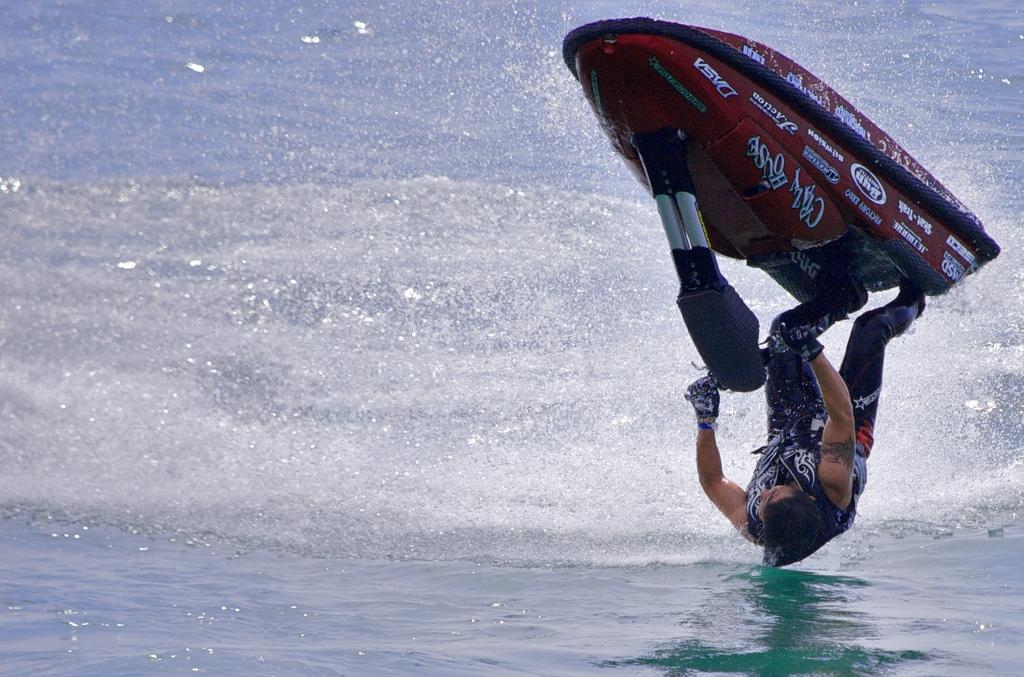What is the main subject of the image? There is a person in the image. What is the person doing in the image? The person is riding a speedboat. What type of environment is visible in the image? There is water visible in the image. How many levels can be seen in the cave in the image? There is no cave present in the image, so it is not possible to determine the number of levels. 